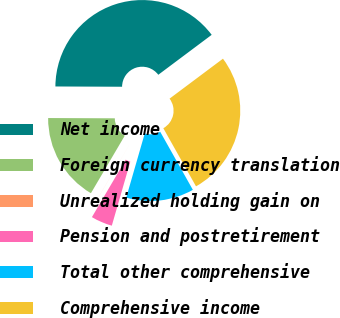Convert chart. <chart><loc_0><loc_0><loc_500><loc_500><pie_chart><fcel>Net income<fcel>Foreign currency translation<fcel>Unrealized holding gain on<fcel>Pension and postretirement<fcel>Total other comprehensive<fcel>Comprehensive income<nl><fcel>39.71%<fcel>16.6%<fcel>0.01%<fcel>3.98%<fcel>12.63%<fcel>27.07%<nl></chart> 